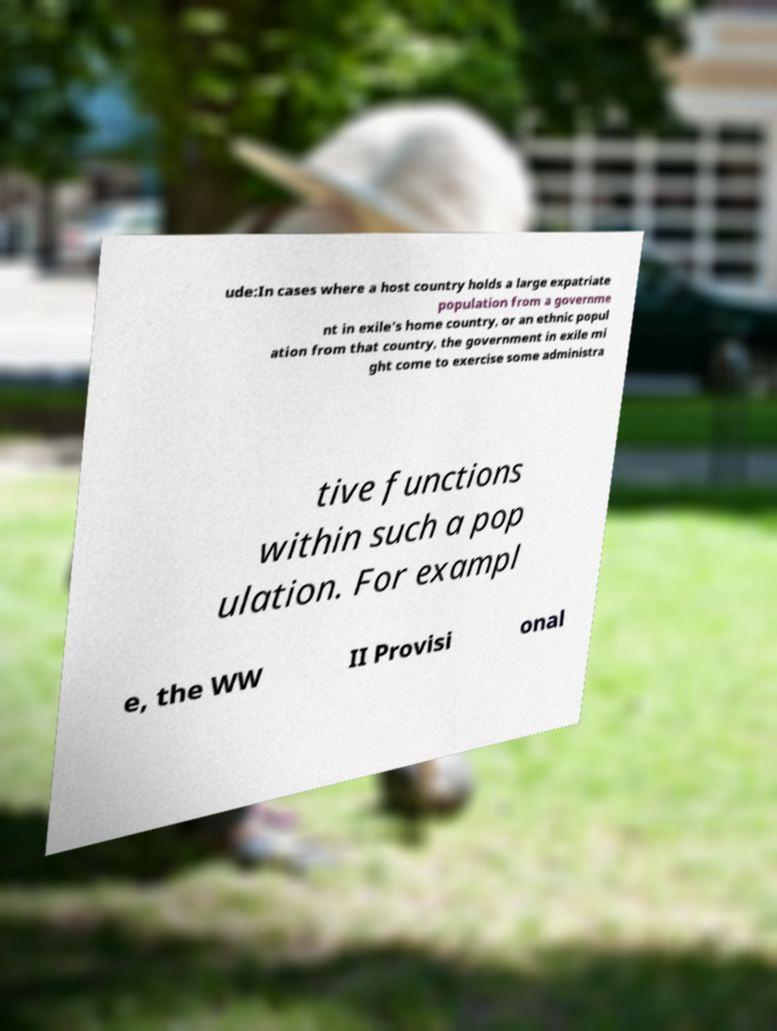Can you read and provide the text displayed in the image?This photo seems to have some interesting text. Can you extract and type it out for me? ude:In cases where a host country holds a large expatriate population from a governme nt in exile's home country, or an ethnic popul ation from that country, the government in exile mi ght come to exercise some administra tive functions within such a pop ulation. For exampl e, the WW II Provisi onal 